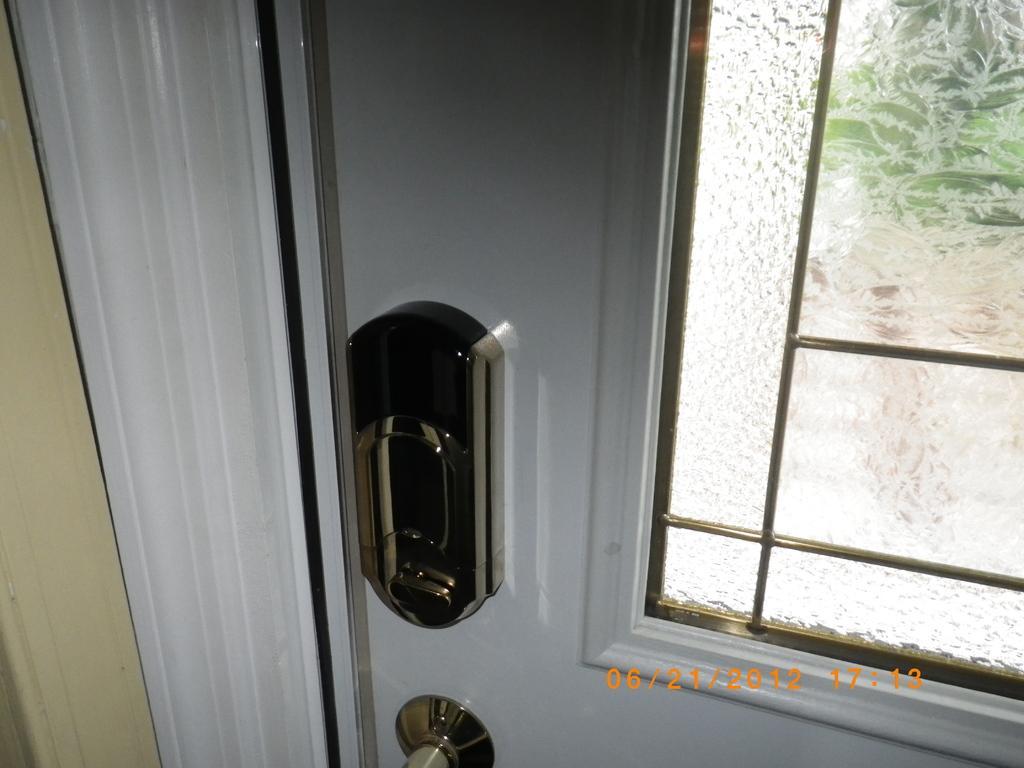Please provide a concise description of this image. In this picture we can see a door and glass, at the bottom of the image we can see timestamp. 